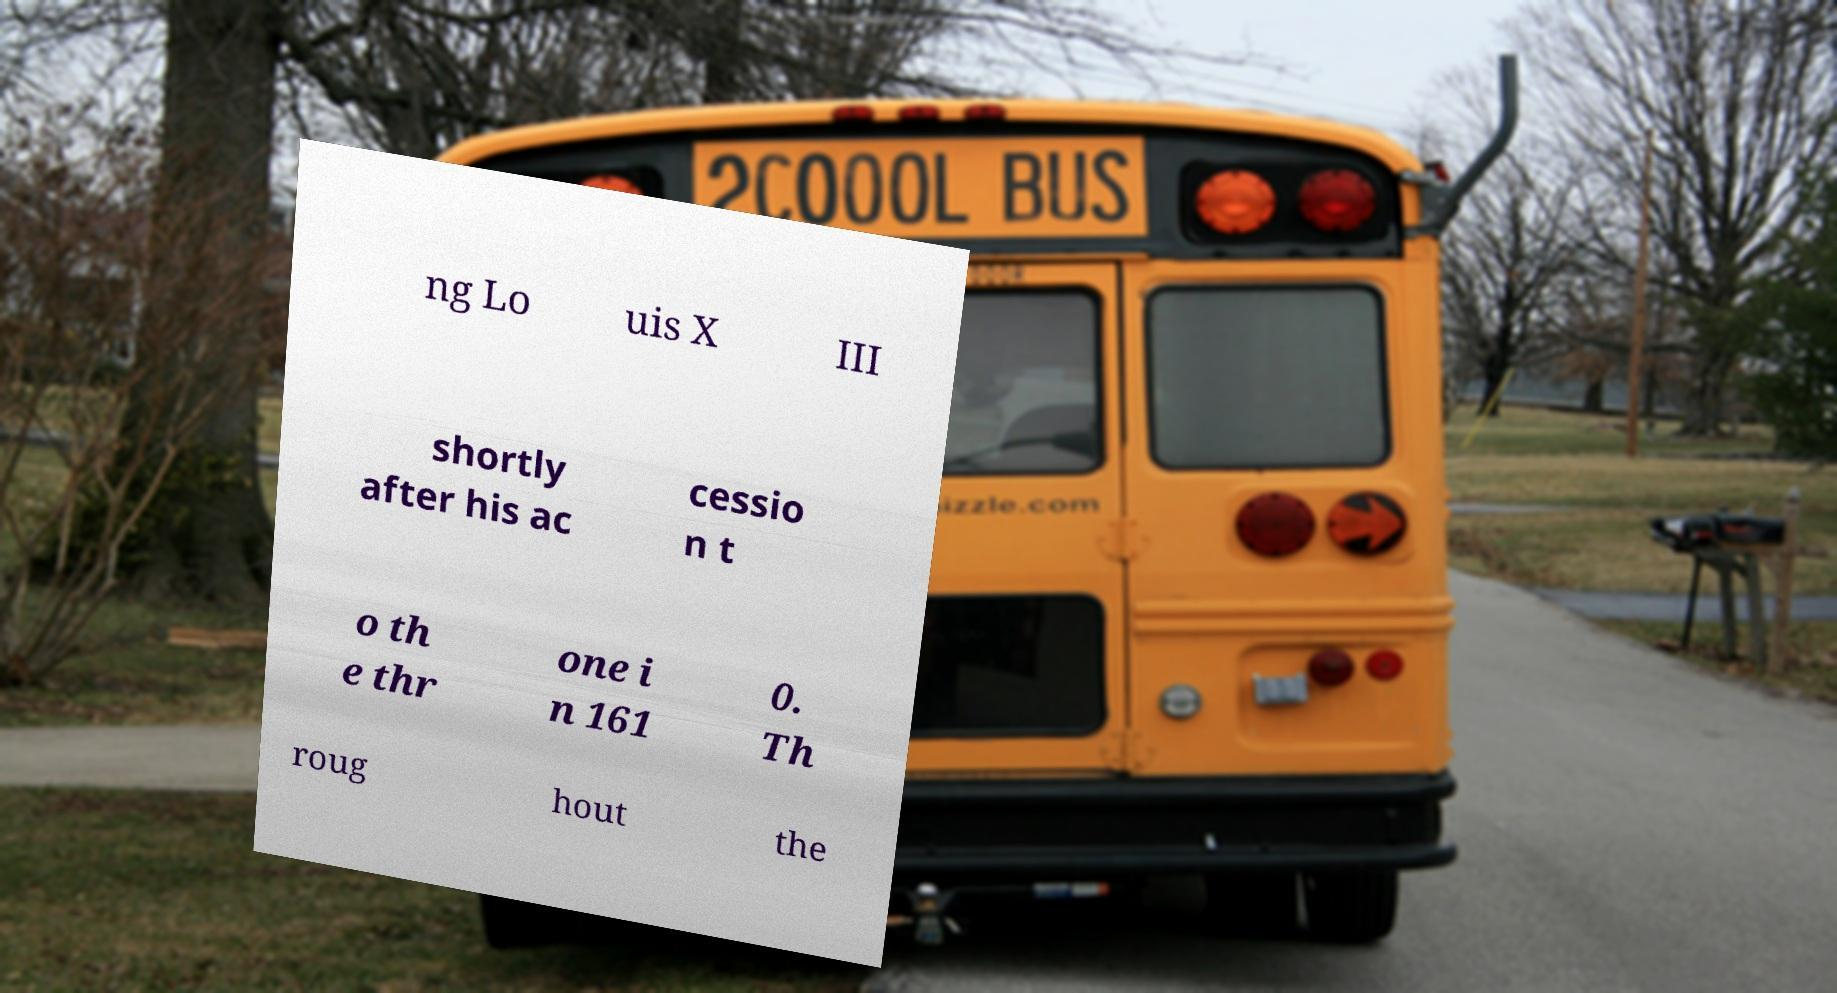Can you accurately transcribe the text from the provided image for me? ng Lo uis X III shortly after his ac cessio n t o th e thr one i n 161 0. Th roug hout the 